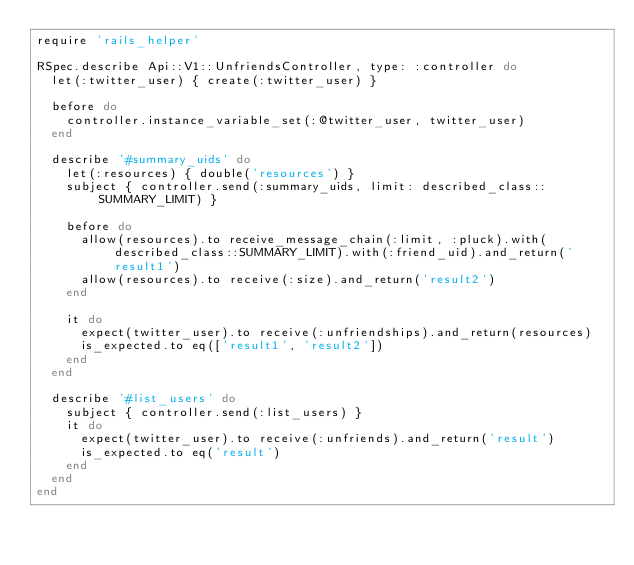Convert code to text. <code><loc_0><loc_0><loc_500><loc_500><_Ruby_>require 'rails_helper'

RSpec.describe Api::V1::UnfriendsController, type: :controller do
  let(:twitter_user) { create(:twitter_user) }

  before do
    controller.instance_variable_set(:@twitter_user, twitter_user)
  end

  describe '#summary_uids' do
    let(:resources) { double('resources') }
    subject { controller.send(:summary_uids, limit: described_class::SUMMARY_LIMIT) }

    before do
      allow(resources).to receive_message_chain(:limit, :pluck).with(described_class::SUMMARY_LIMIT).with(:friend_uid).and_return('result1')
      allow(resources).to receive(:size).and_return('result2')
    end

    it do
      expect(twitter_user).to receive(:unfriendships).and_return(resources)
      is_expected.to eq(['result1', 'result2'])
    end
  end

  describe '#list_users' do
    subject { controller.send(:list_users) }
    it do
      expect(twitter_user).to receive(:unfriends).and_return('result')
      is_expected.to eq('result')
    end
  end
end
</code> 